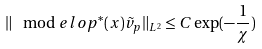Convert formula to latex. <formula><loc_0><loc_0><loc_500><loc_500>\| \mod e l o p ^ { \ast } ( x ) \tilde { v } _ { p } \| _ { L ^ { 2 } } \leq C \exp ( - \frac { 1 } { \chi } )</formula> 